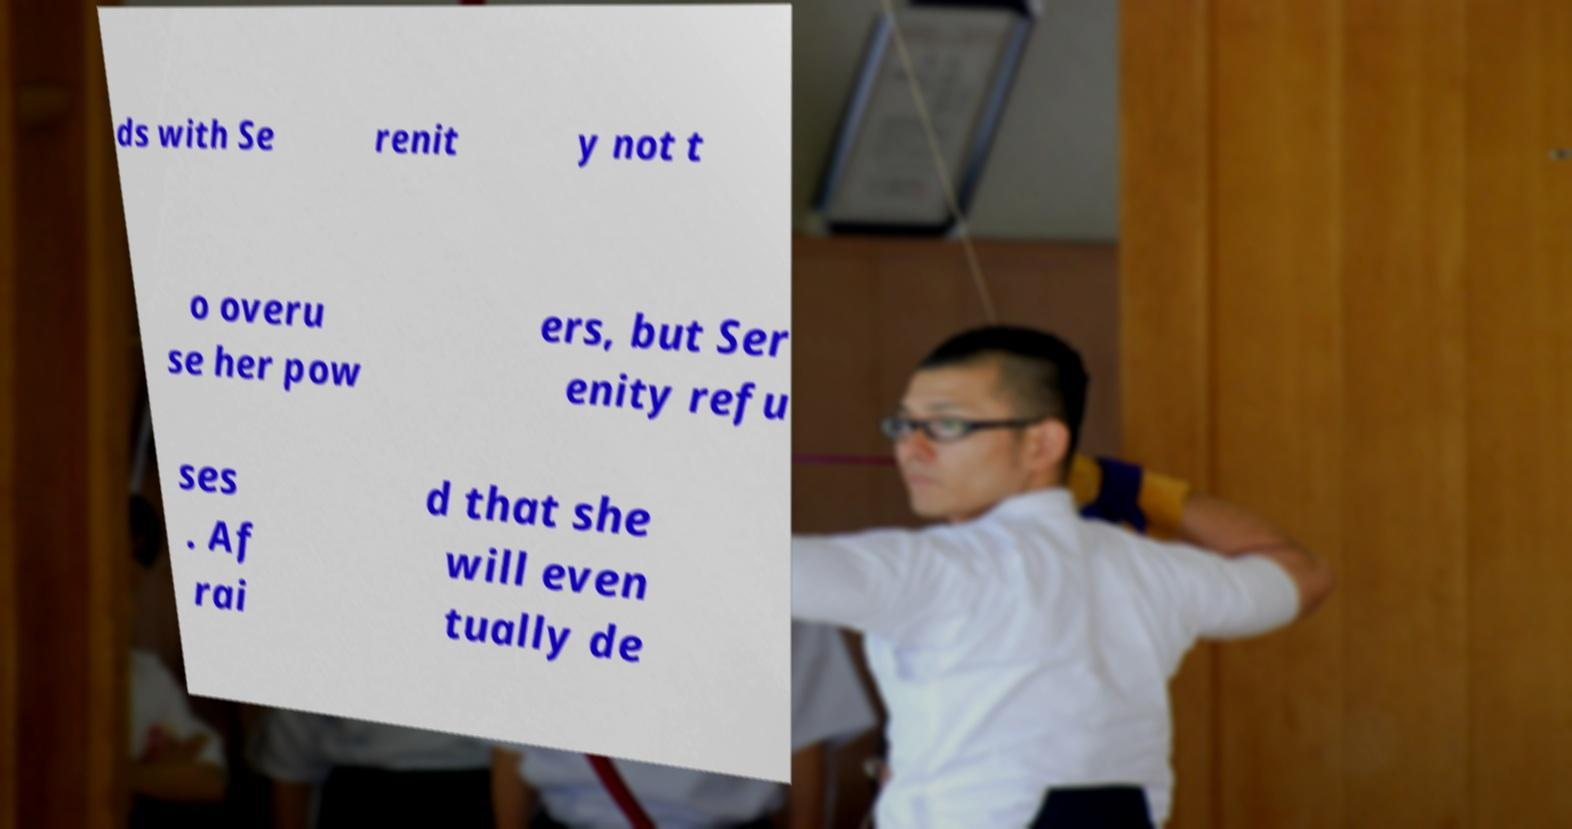Can you read and provide the text displayed in the image?This photo seems to have some interesting text. Can you extract and type it out for me? ds with Se renit y not t o overu se her pow ers, but Ser enity refu ses . Af rai d that she will even tually de 